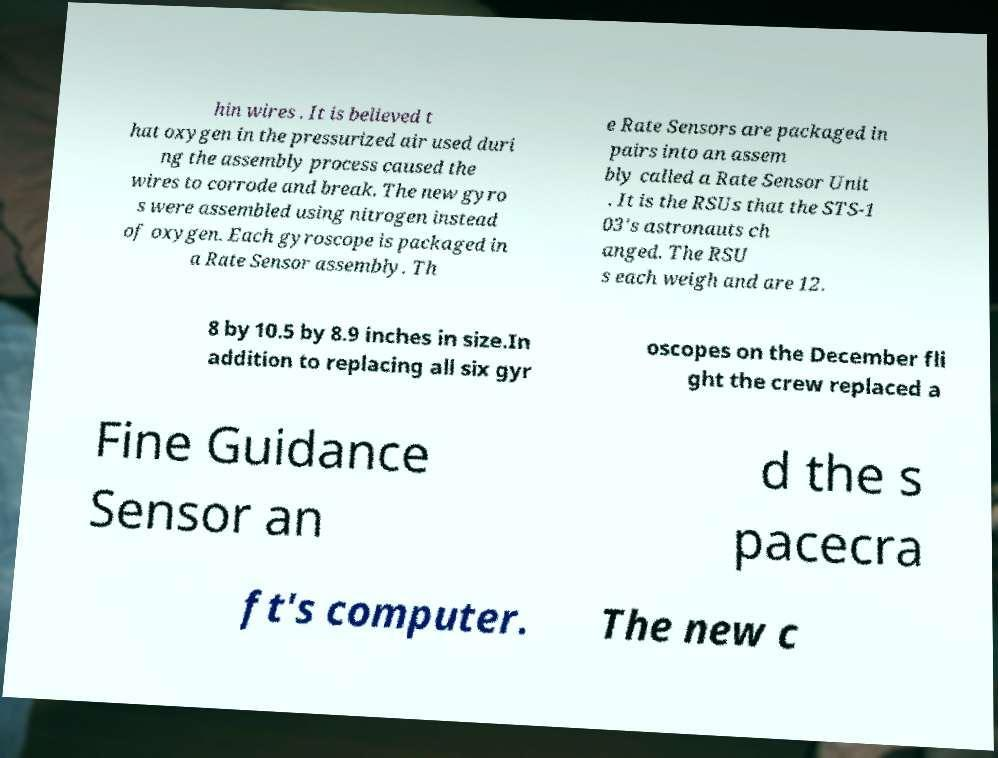I need the written content from this picture converted into text. Can you do that? hin wires . It is believed t hat oxygen in the pressurized air used duri ng the assembly process caused the wires to corrode and break. The new gyro s were assembled using nitrogen instead of oxygen. Each gyroscope is packaged in a Rate Sensor assembly. Th e Rate Sensors are packaged in pairs into an assem bly called a Rate Sensor Unit . It is the RSUs that the STS-1 03's astronauts ch anged. The RSU s each weigh and are 12. 8 by 10.5 by 8.9 inches in size.In addition to replacing all six gyr oscopes on the December fli ght the crew replaced a Fine Guidance Sensor an d the s pacecra ft's computer. The new c 